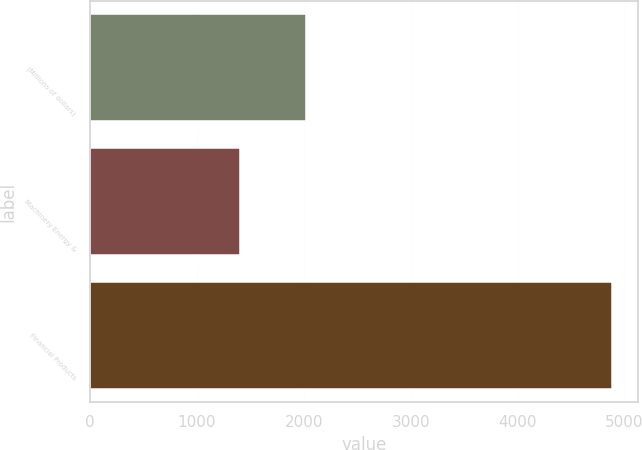Convert chart to OTSL. <chart><loc_0><loc_0><loc_500><loc_500><bar_chart><fcel>(Millions of dollars)<fcel>Machinery Energy &<fcel>Financial Products<nl><fcel>2021<fcel>1398<fcel>4884<nl></chart> 